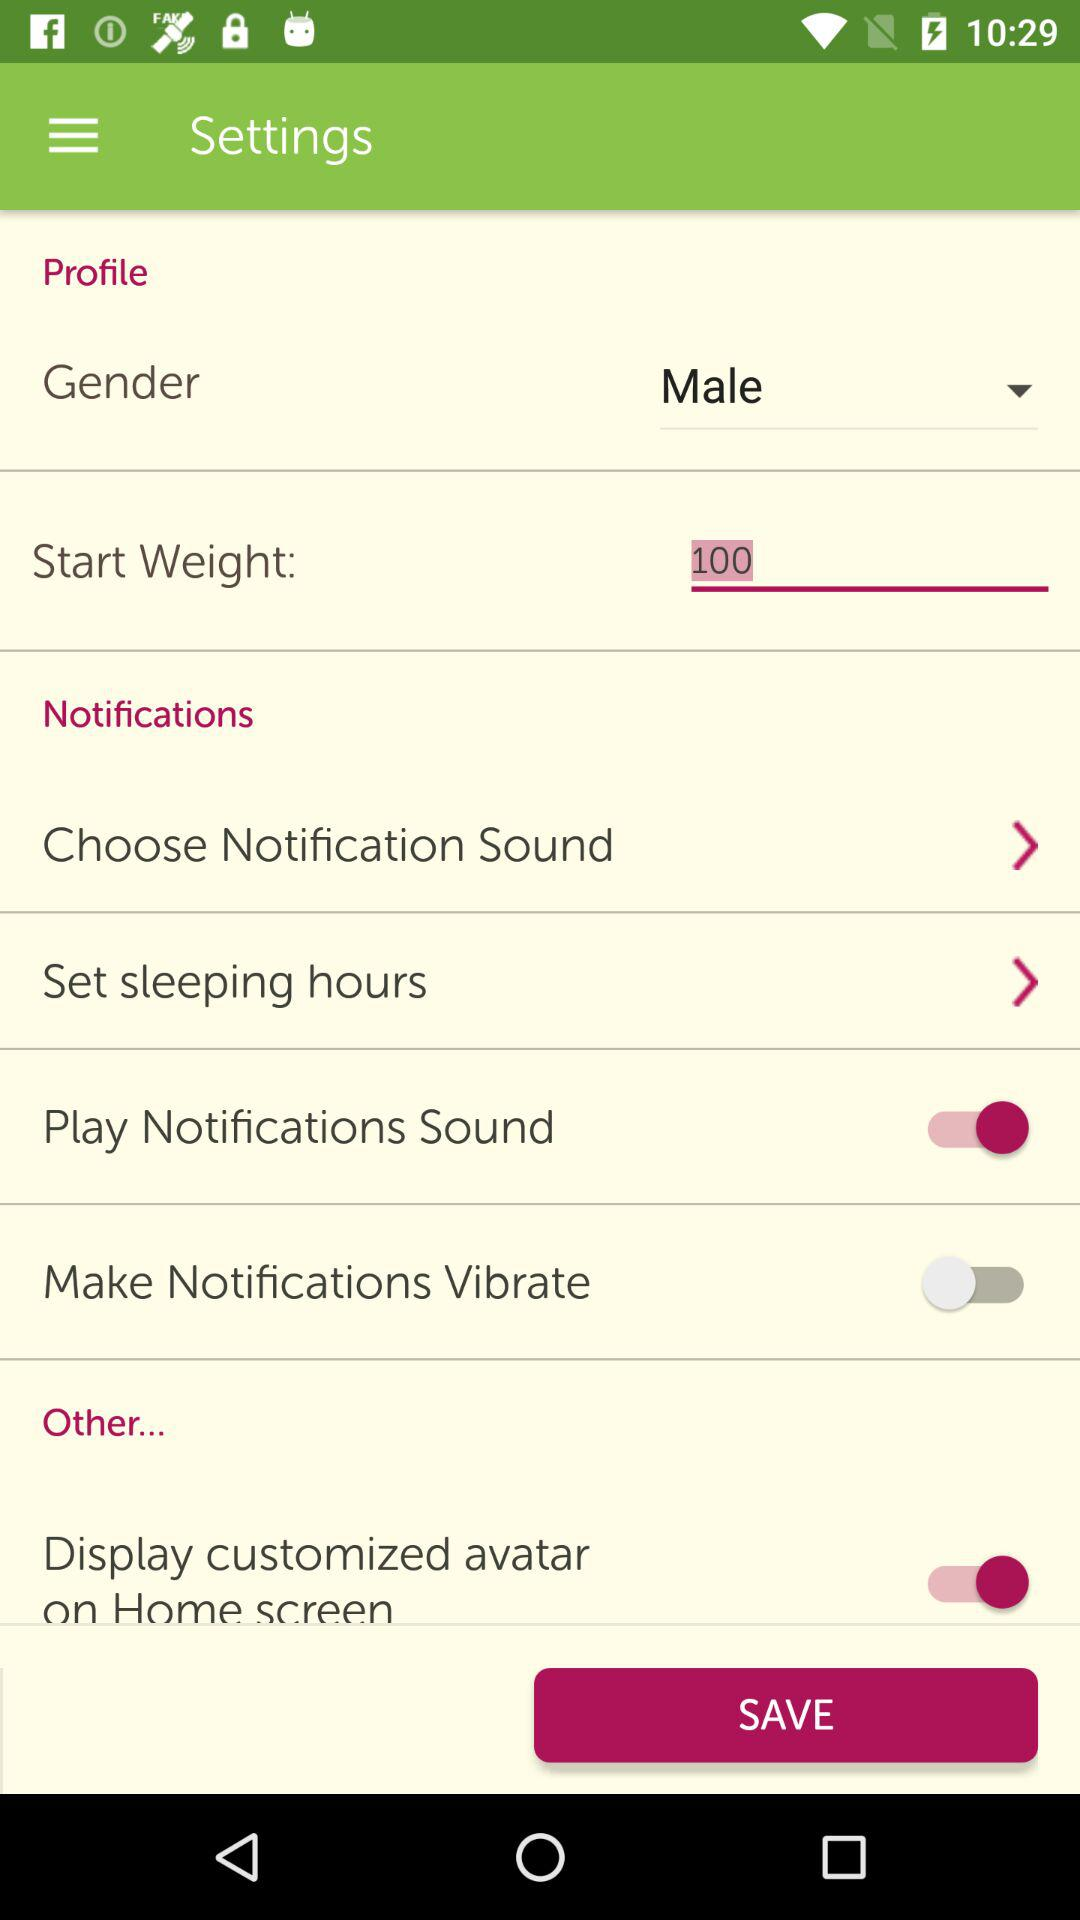What is the value mentioned for "Start Weight"? The mentioned value is 100. 